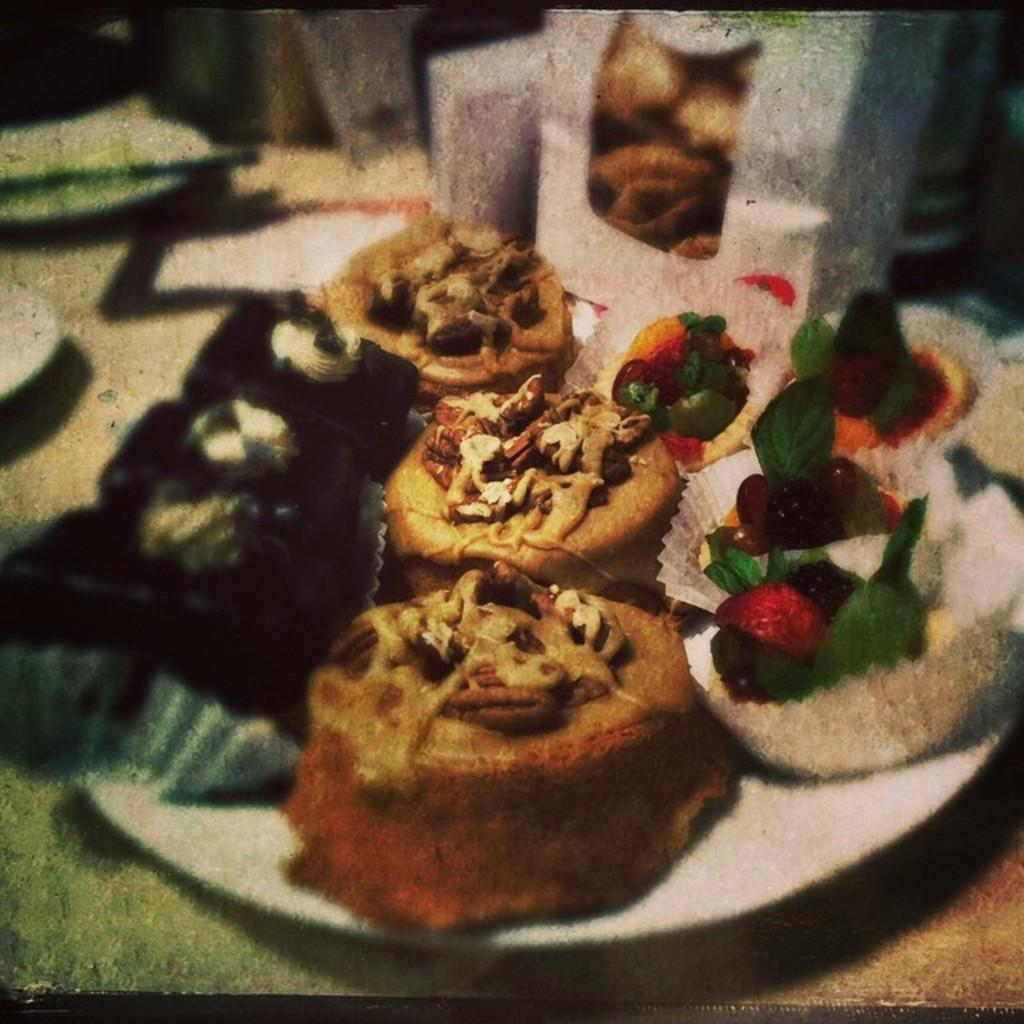What is on the plate in the image? There are food items on the plate in the image. What else can be seen on the table besides the plate? There are glasses on the table in the image. Can you describe the setting where the image was taken? The image may have been taken in a room, as there is no indication of an outdoor setting. How many cans of volleyball are visible in the image? There are no cans of volleyball present in the image. 